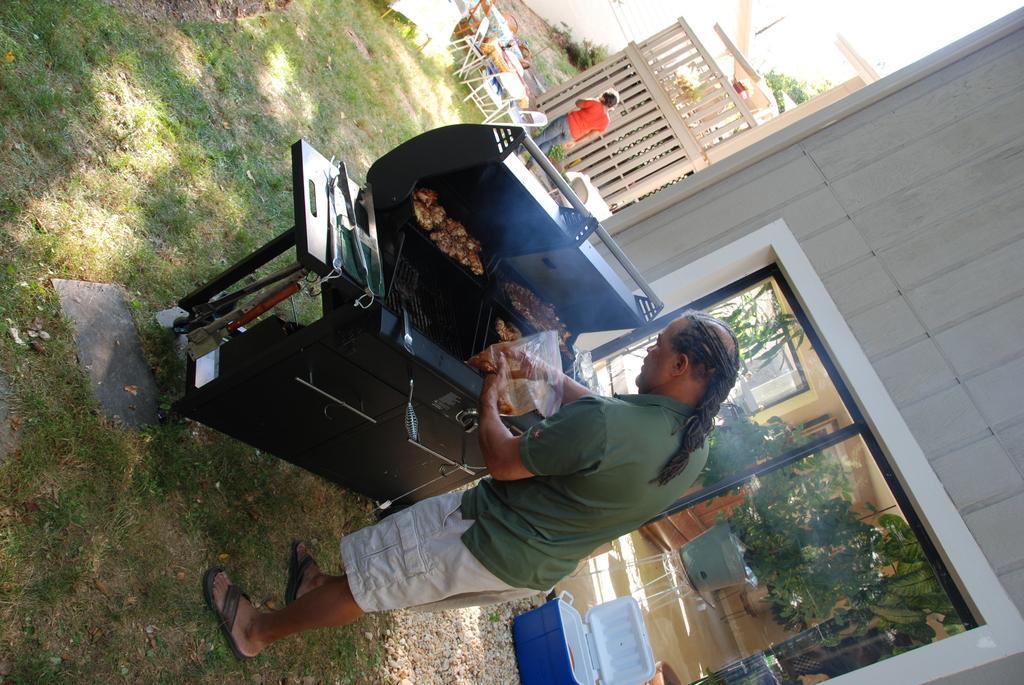Could you give a brief overview of what you see in this image? At the bottom of this image, there is a person in a T-shirt, holding a packet, and taking something from it. In front of him, there are food items in a pan which is on a stove. In the background, there are plants, a person, chairs arranged on the ground and there is a building. 